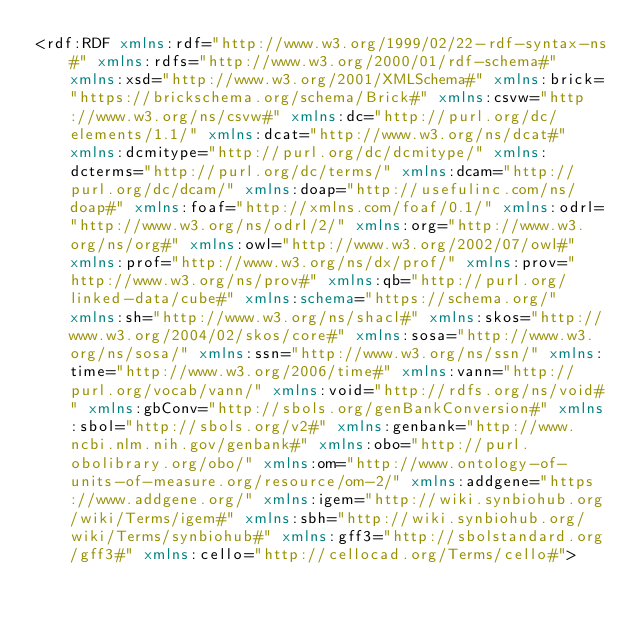<code> <loc_0><loc_0><loc_500><loc_500><_XML_><rdf:RDF xmlns:rdf="http://www.w3.org/1999/02/22-rdf-syntax-ns#" xmlns:rdfs="http://www.w3.org/2000/01/rdf-schema#" xmlns:xsd="http://www.w3.org/2001/XMLSchema#" xmlns:brick="https://brickschema.org/schema/Brick#" xmlns:csvw="http://www.w3.org/ns/csvw#" xmlns:dc="http://purl.org/dc/elements/1.1/" xmlns:dcat="http://www.w3.org/ns/dcat#" xmlns:dcmitype="http://purl.org/dc/dcmitype/" xmlns:dcterms="http://purl.org/dc/terms/" xmlns:dcam="http://purl.org/dc/dcam/" xmlns:doap="http://usefulinc.com/ns/doap#" xmlns:foaf="http://xmlns.com/foaf/0.1/" xmlns:odrl="http://www.w3.org/ns/odrl/2/" xmlns:org="http://www.w3.org/ns/org#" xmlns:owl="http://www.w3.org/2002/07/owl#" xmlns:prof="http://www.w3.org/ns/dx/prof/" xmlns:prov="http://www.w3.org/ns/prov#" xmlns:qb="http://purl.org/linked-data/cube#" xmlns:schema="https://schema.org/" xmlns:sh="http://www.w3.org/ns/shacl#" xmlns:skos="http://www.w3.org/2004/02/skos/core#" xmlns:sosa="http://www.w3.org/ns/sosa/" xmlns:ssn="http://www.w3.org/ns/ssn/" xmlns:time="http://www.w3.org/2006/time#" xmlns:vann="http://purl.org/vocab/vann/" xmlns:void="http://rdfs.org/ns/void#" xmlns:gbConv="http://sbols.org/genBankConversion#" xmlns:sbol="http://sbols.org/v2#" xmlns:genbank="http://www.ncbi.nlm.nih.gov/genbank#" xmlns:obo="http://purl.obolibrary.org/obo/" xmlns:om="http://www.ontology-of-units-of-measure.org/resource/om-2/" xmlns:addgene="https://www.addgene.org/" xmlns:igem="http://wiki.synbiohub.org/wiki/Terms/igem#" xmlns:sbh="http://wiki.synbiohub.org/wiki/Terms/synbiohub#" xmlns:gff3="http://sbolstandard.org/gff3#" xmlns:cello="http://cellocad.org/Terms/cello#"></code> 